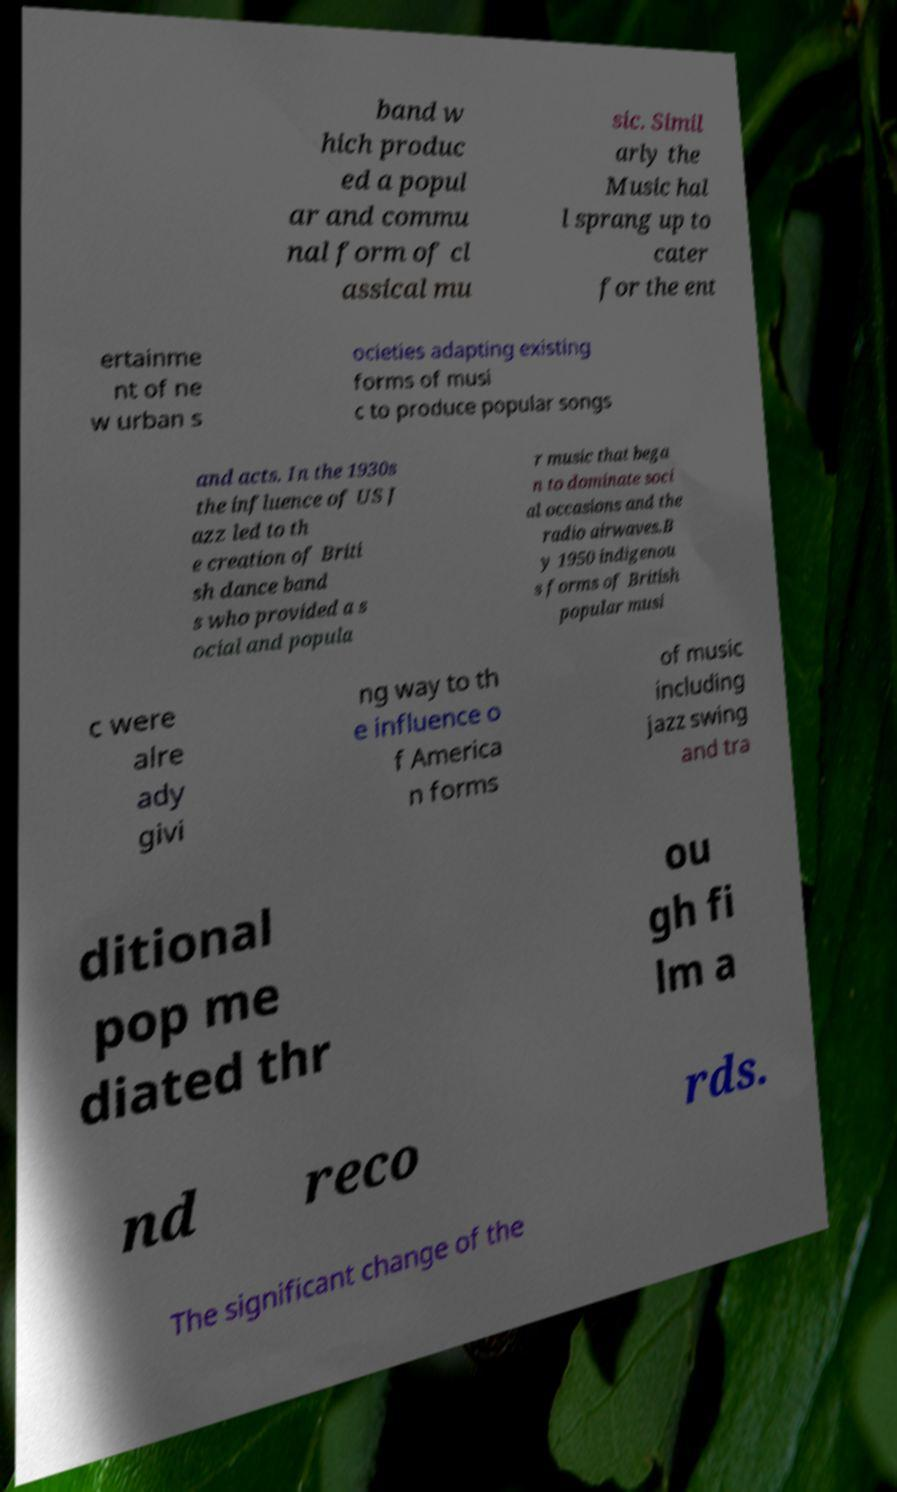For documentation purposes, I need the text within this image transcribed. Could you provide that? band w hich produc ed a popul ar and commu nal form of cl assical mu sic. Simil arly the Music hal l sprang up to cater for the ent ertainme nt of ne w urban s ocieties adapting existing forms of musi c to produce popular songs and acts. In the 1930s the influence of US J azz led to th e creation of Briti sh dance band s who provided a s ocial and popula r music that bega n to dominate soci al occasions and the radio airwaves.B y 1950 indigenou s forms of British popular musi c were alre ady givi ng way to th e influence o f America n forms of music including jazz swing and tra ditional pop me diated thr ou gh fi lm a nd reco rds. The significant change of the 